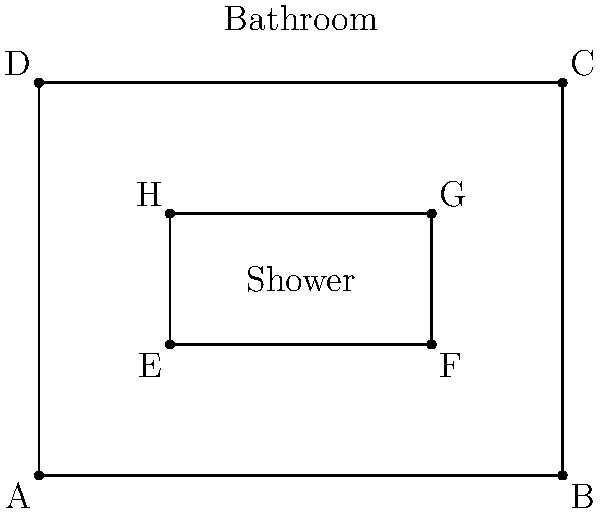In the bathroom layout shown, the shower enclosure EFGH is positioned within the larger bathroom ABCD. If the shower enclosure is congruent to a scaled-down version of the bathroom, what is the scale factor between the two rectangles? To determine the scale factor between the bathroom and the shower enclosure, we need to compare their corresponding dimensions. Let's solve this step-by-step:

1. Identify the dimensions of the bathroom (ABCD):
   Length: $AB = 4$ units
   Width: $AD = 3$ units

2. Identify the dimensions of the shower enclosure (EFGH):
   Length: $EF = 2$ units
   Width: $EH = 1$ unit

3. Calculate the scale factor for length:
   $\text{Scale factor}_{\text{length}} = \frac{EF}{AB} = \frac{2}{4} = \frac{1}{2}$

4. Calculate the scale factor for width:
   $\text{Scale factor}_{\text{width}} = \frac{EH}{AD} = \frac{1}{3}$

5. For the shower enclosure to be congruent to a scaled-down version of the bathroom, both scale factors must be equal. We can see that:

   $\frac{1}{2} \neq \frac{1}{3}$

6. Therefore, the shower enclosure is not congruent to a scaled-down version of the bathroom.

However, if we assume that the question implies congruence, we should use the length scale factor as it's more commonly used in plumbing layouts:

$\text{Scale factor} = \frac{1}{2}$

This means the shower enclosure is half the size of the bathroom in each dimension.
Answer: $\frac{1}{2}$ 